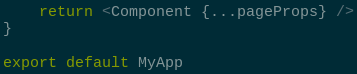Convert code to text. <code><loc_0><loc_0><loc_500><loc_500><_TypeScript_>	return <Component {...pageProps} />
}

export default MyApp
</code> 